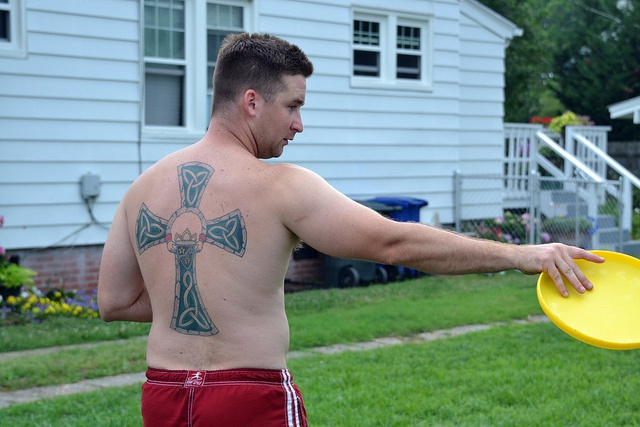Describe the objects in this image and their specific colors. I can see people in blue, darkgray, gray, and maroon tones and frisbee in blue, khaki, and gold tones in this image. 